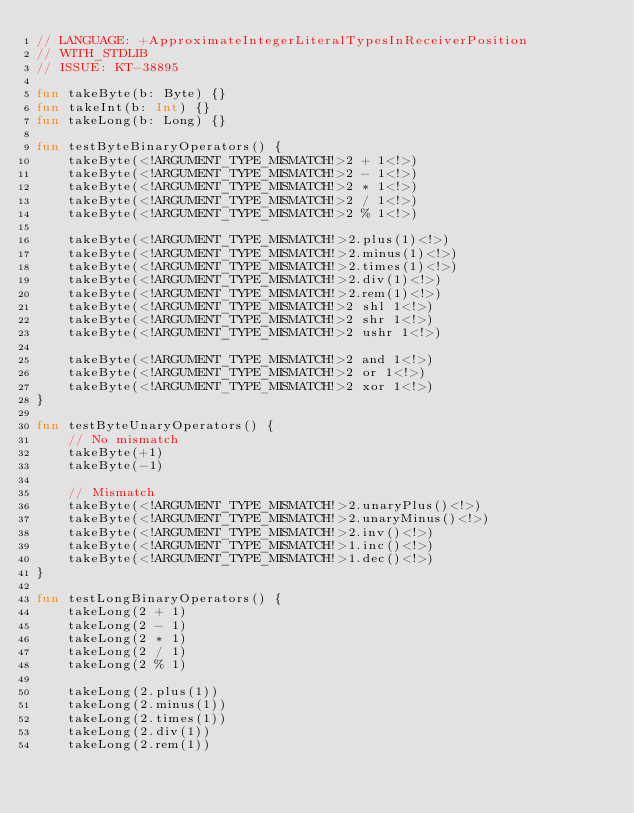Convert code to text. <code><loc_0><loc_0><loc_500><loc_500><_Kotlin_>// LANGUAGE: +ApproximateIntegerLiteralTypesInReceiverPosition
// WITH_STDLIB
// ISSUE: KT-38895

fun takeByte(b: Byte) {}
fun takeInt(b: Int) {}
fun takeLong(b: Long) {}

fun testByteBinaryOperators() {
    takeByte(<!ARGUMENT_TYPE_MISMATCH!>2 + 1<!>)
    takeByte(<!ARGUMENT_TYPE_MISMATCH!>2 - 1<!>)
    takeByte(<!ARGUMENT_TYPE_MISMATCH!>2 * 1<!>)
    takeByte(<!ARGUMENT_TYPE_MISMATCH!>2 / 1<!>)
    takeByte(<!ARGUMENT_TYPE_MISMATCH!>2 % 1<!>)

    takeByte(<!ARGUMENT_TYPE_MISMATCH!>2.plus(1)<!>)
    takeByte(<!ARGUMENT_TYPE_MISMATCH!>2.minus(1)<!>)
    takeByte(<!ARGUMENT_TYPE_MISMATCH!>2.times(1)<!>)
    takeByte(<!ARGUMENT_TYPE_MISMATCH!>2.div(1)<!>)
    takeByte(<!ARGUMENT_TYPE_MISMATCH!>2.rem(1)<!>)
    takeByte(<!ARGUMENT_TYPE_MISMATCH!>2 shl 1<!>)
    takeByte(<!ARGUMENT_TYPE_MISMATCH!>2 shr 1<!>)
    takeByte(<!ARGUMENT_TYPE_MISMATCH!>2 ushr 1<!>)

    takeByte(<!ARGUMENT_TYPE_MISMATCH!>2 and 1<!>)
    takeByte(<!ARGUMENT_TYPE_MISMATCH!>2 or 1<!>)
    takeByte(<!ARGUMENT_TYPE_MISMATCH!>2 xor 1<!>)
}

fun testByteUnaryOperators() {
    // No mismatch
    takeByte(+1)
    takeByte(-1)

    // Mismatch
    takeByte(<!ARGUMENT_TYPE_MISMATCH!>2.unaryPlus()<!>)
    takeByte(<!ARGUMENT_TYPE_MISMATCH!>2.unaryMinus()<!>)
    takeByte(<!ARGUMENT_TYPE_MISMATCH!>2.inv()<!>)
    takeByte(<!ARGUMENT_TYPE_MISMATCH!>1.inc()<!>)
    takeByte(<!ARGUMENT_TYPE_MISMATCH!>1.dec()<!>)
}

fun testLongBinaryOperators() {
    takeLong(2 + 1)
    takeLong(2 - 1)
    takeLong(2 * 1)
    takeLong(2 / 1)
    takeLong(2 % 1)

    takeLong(2.plus(1))
    takeLong(2.minus(1))
    takeLong(2.times(1))
    takeLong(2.div(1))
    takeLong(2.rem(1))</code> 